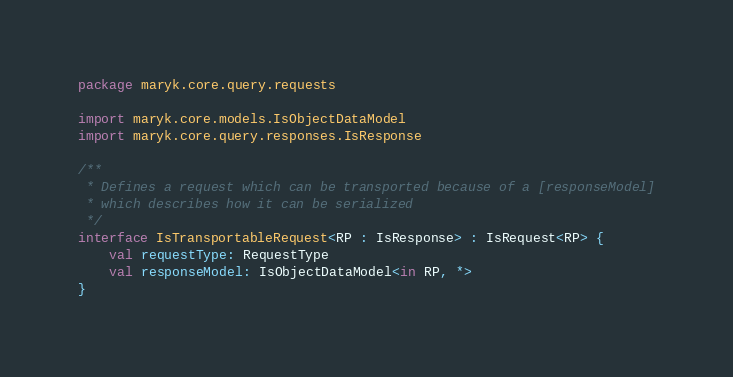Convert code to text. <code><loc_0><loc_0><loc_500><loc_500><_Kotlin_>package maryk.core.query.requests

import maryk.core.models.IsObjectDataModel
import maryk.core.query.responses.IsResponse

/**
 * Defines a request which can be transported because of a [responseModel]
 * which describes how it can be serialized
 */
interface IsTransportableRequest<RP : IsResponse> : IsRequest<RP> {
    val requestType: RequestType
    val responseModel: IsObjectDataModel<in RP, *>
}
</code> 